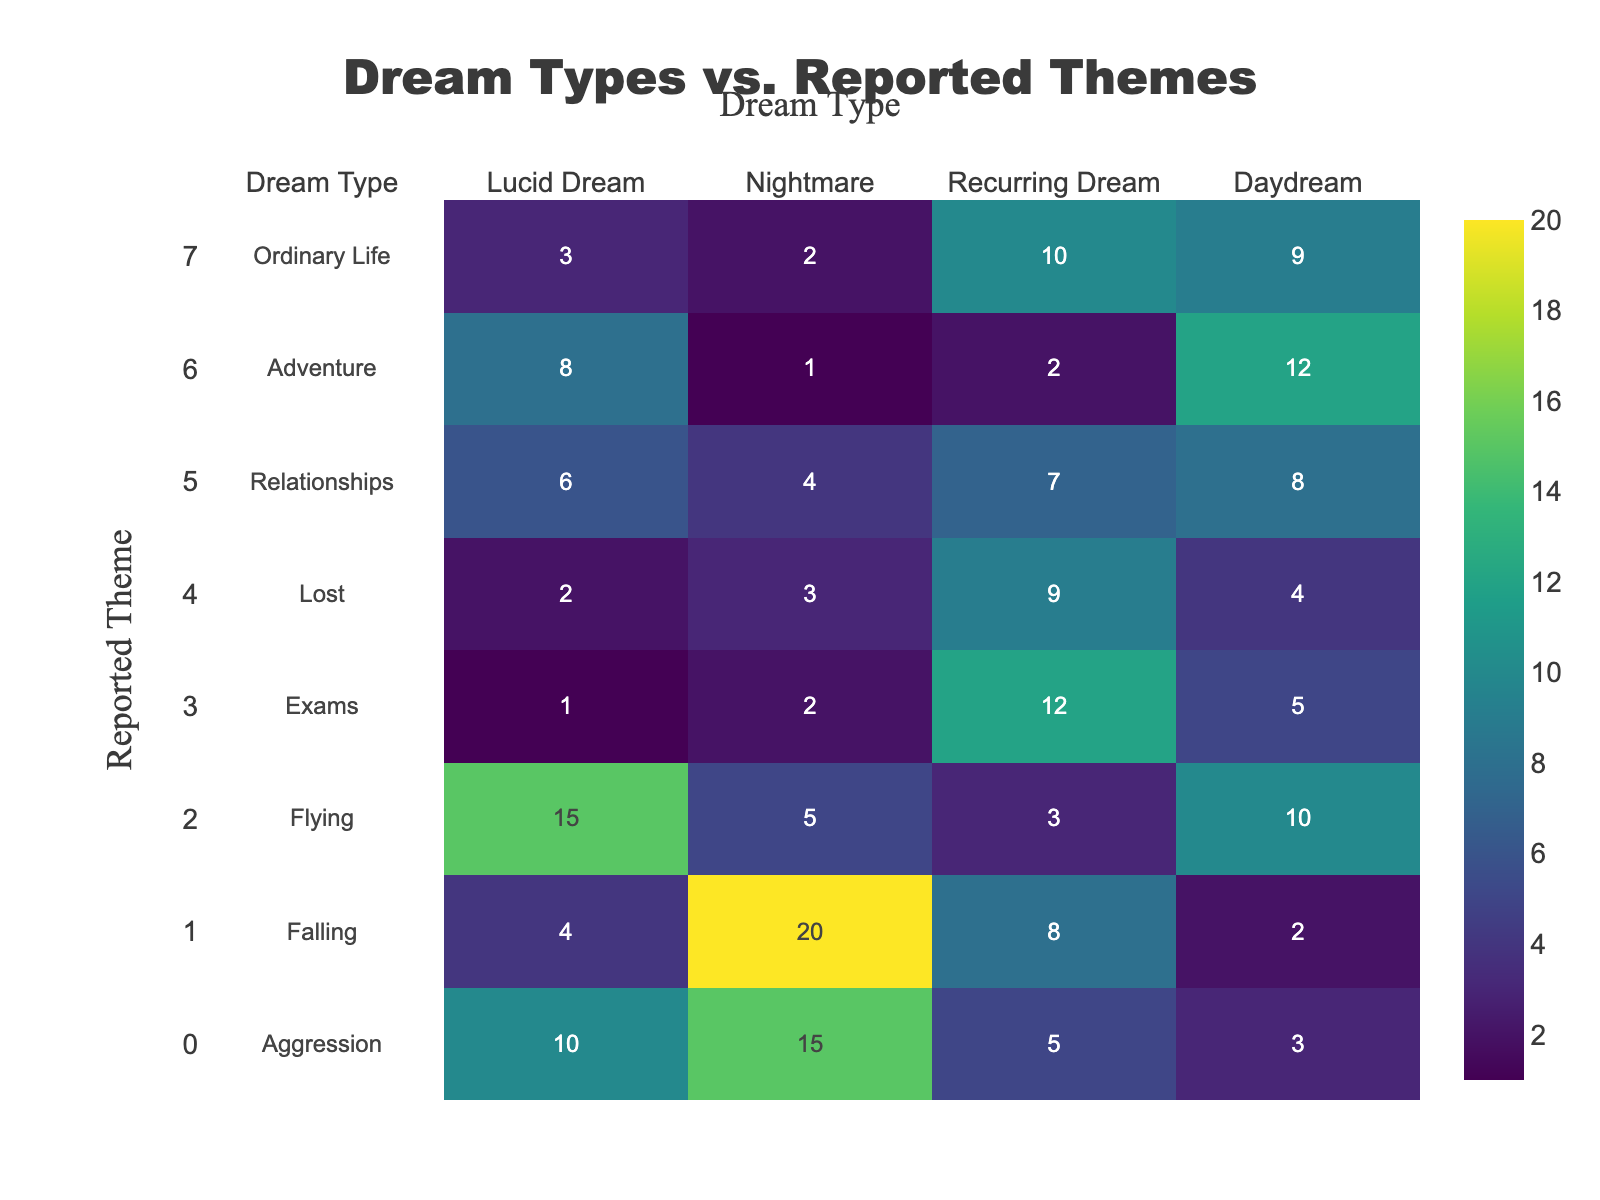What is the total number of reported nightmares across all dream types? To find the total number of nightmares, I will look at the column for "Nightmare" and sum the values: 15 (Aggression) + 20 (Falling) + 5 (Flying) + 2 (Exams) + 3 (Lost) + 4 (Relationships) + 1 (Adventure) + 2 (Ordinary Life) = 52
Answer: 52 Which dream type has the highest number of occurrences related to falling? To answer this, I look at the row for "Falling" and determine the values: Nightmare (20) has the highest occurrence when compared to Aggression (4), Recurring Dream (8), and Daydream (2). Therefore, the highest number is from the Nightmare category.
Answer: Nightmare What is the average number of dreams related to relationships? To calculate the average for the "Relationships" row, I will take the values (6, 4, 7, 8) and sum them up: 6 + 4 + 7 + 8 = 25. There are four categories, so the average is 25/4 = 6.25.
Answer: 6.25 Are there more dreams categorized as daydreams or nightmares in total? First, I will sum the total for both "Daydream" and "Nightmare". For Daydream: 3 + 2 + 10 + 5 + 4 + 8 + 12 + 9 = 53. For Nightmare: 15 + 20 + 5 + 2 + 3 + 4 + 1 + 2 = 52. Since 53 (daydream) is greater than 52 (nightmare), the answer is yes.
Answer: Yes Which reported theme has the highest total number of dreams across all categories? To find which theme has the highest count, sum the values in each row: Aggression (33), Falling (34), Flying (38), Exams (20), Lost (18), Relationships (25), Adventure (23), Ordinary Life (24). The maximum among these sums is Flying (38).
Answer: Flying 